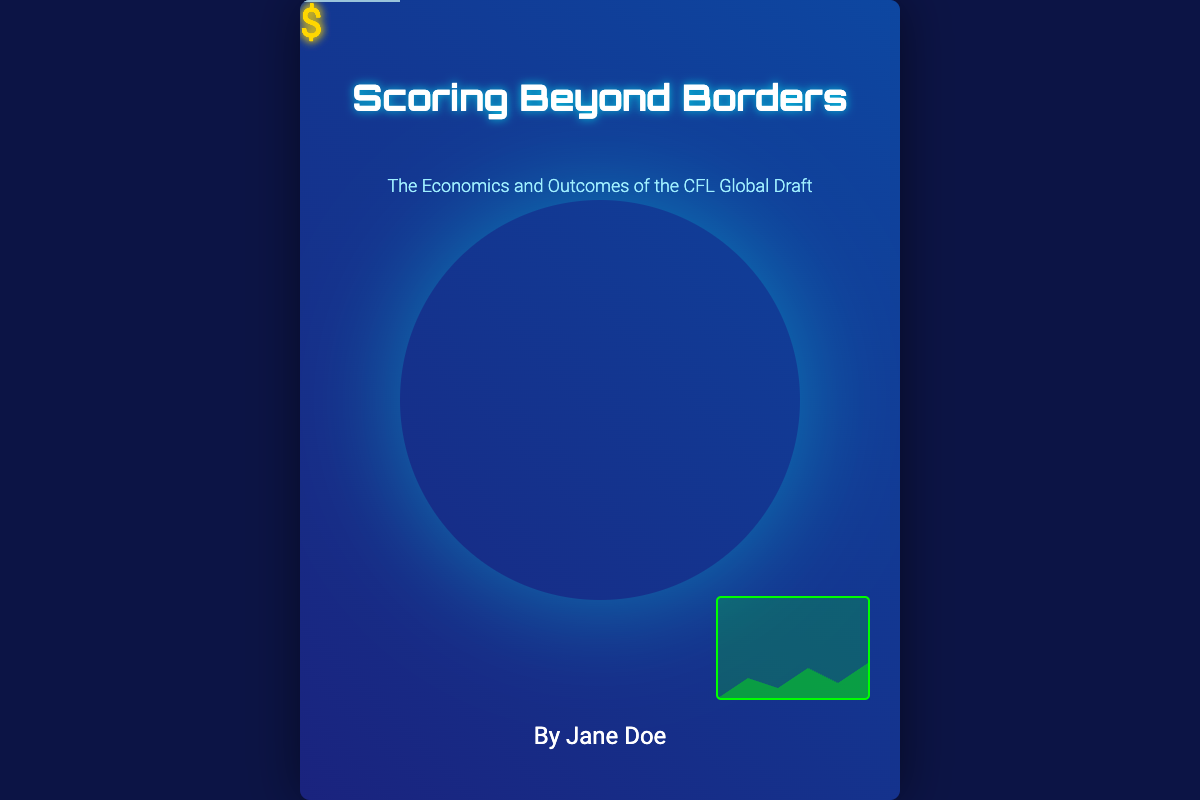What is the title of the book? The title of the book is prominently displayed at the top of the cover.
Answer: Scoring Beyond Borders Who is the author of the book? The author's name is located at the bottom of the cover.
Answer: Jane Doe What is the subtitle of the book? The subtitle, providing additional context about the book's content, is located just below the title.
Answer: The Economics and Outcomes of the CFL Global Draft What is the color of the background? The background is a gradient of two colors, which can be seen clearly from the visual design.
Answer: Blue How many dollar signs are displayed on the cover? The cover includes several dollar signs, illustrating the economic focus of the book.
Answer: Three What type of graphic is featured prominently on the cover? The main graphic, central to the book's theme, is depicted as a globe.
Answer: Globe What is the purpose of the dollar signs on the cover? The dollar signs symbolize economic implications related to the contents of the book.
Answer: Economic symbolism Where is the graph located on the cover? The graph is positioned at the bottom right corner of the cover, contributing to the design.
Answer: Bottom right What is the overall theme of the book? The theme focuses on the implications and outcomes of a specific aspect of Canadian football.
Answer: CFL Global Draft 